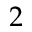Convert formula to latex. <formula><loc_0><loc_0><loc_500><loc_500>2</formula> 